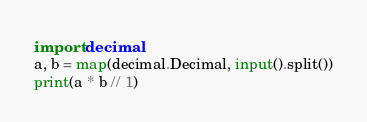Convert code to text. <code><loc_0><loc_0><loc_500><loc_500><_Python_>import decimal
a, b = map(decimal.Decimal, input().split())
print(a * b // 1)</code> 